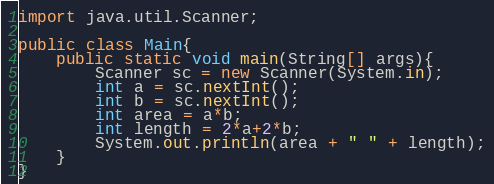<code> <loc_0><loc_0><loc_500><loc_500><_Java_>import java.util.Scanner;

public class Main{
    public static void main(String[] args){
        Scanner sc = new Scanner(System.in);
        int a = sc.nextInt();
        int b = sc.nextInt();
        int area = a*b;
        int length = 2*a+2*b;
        System.out.println(area + " " + length);
    }
}
</code> 